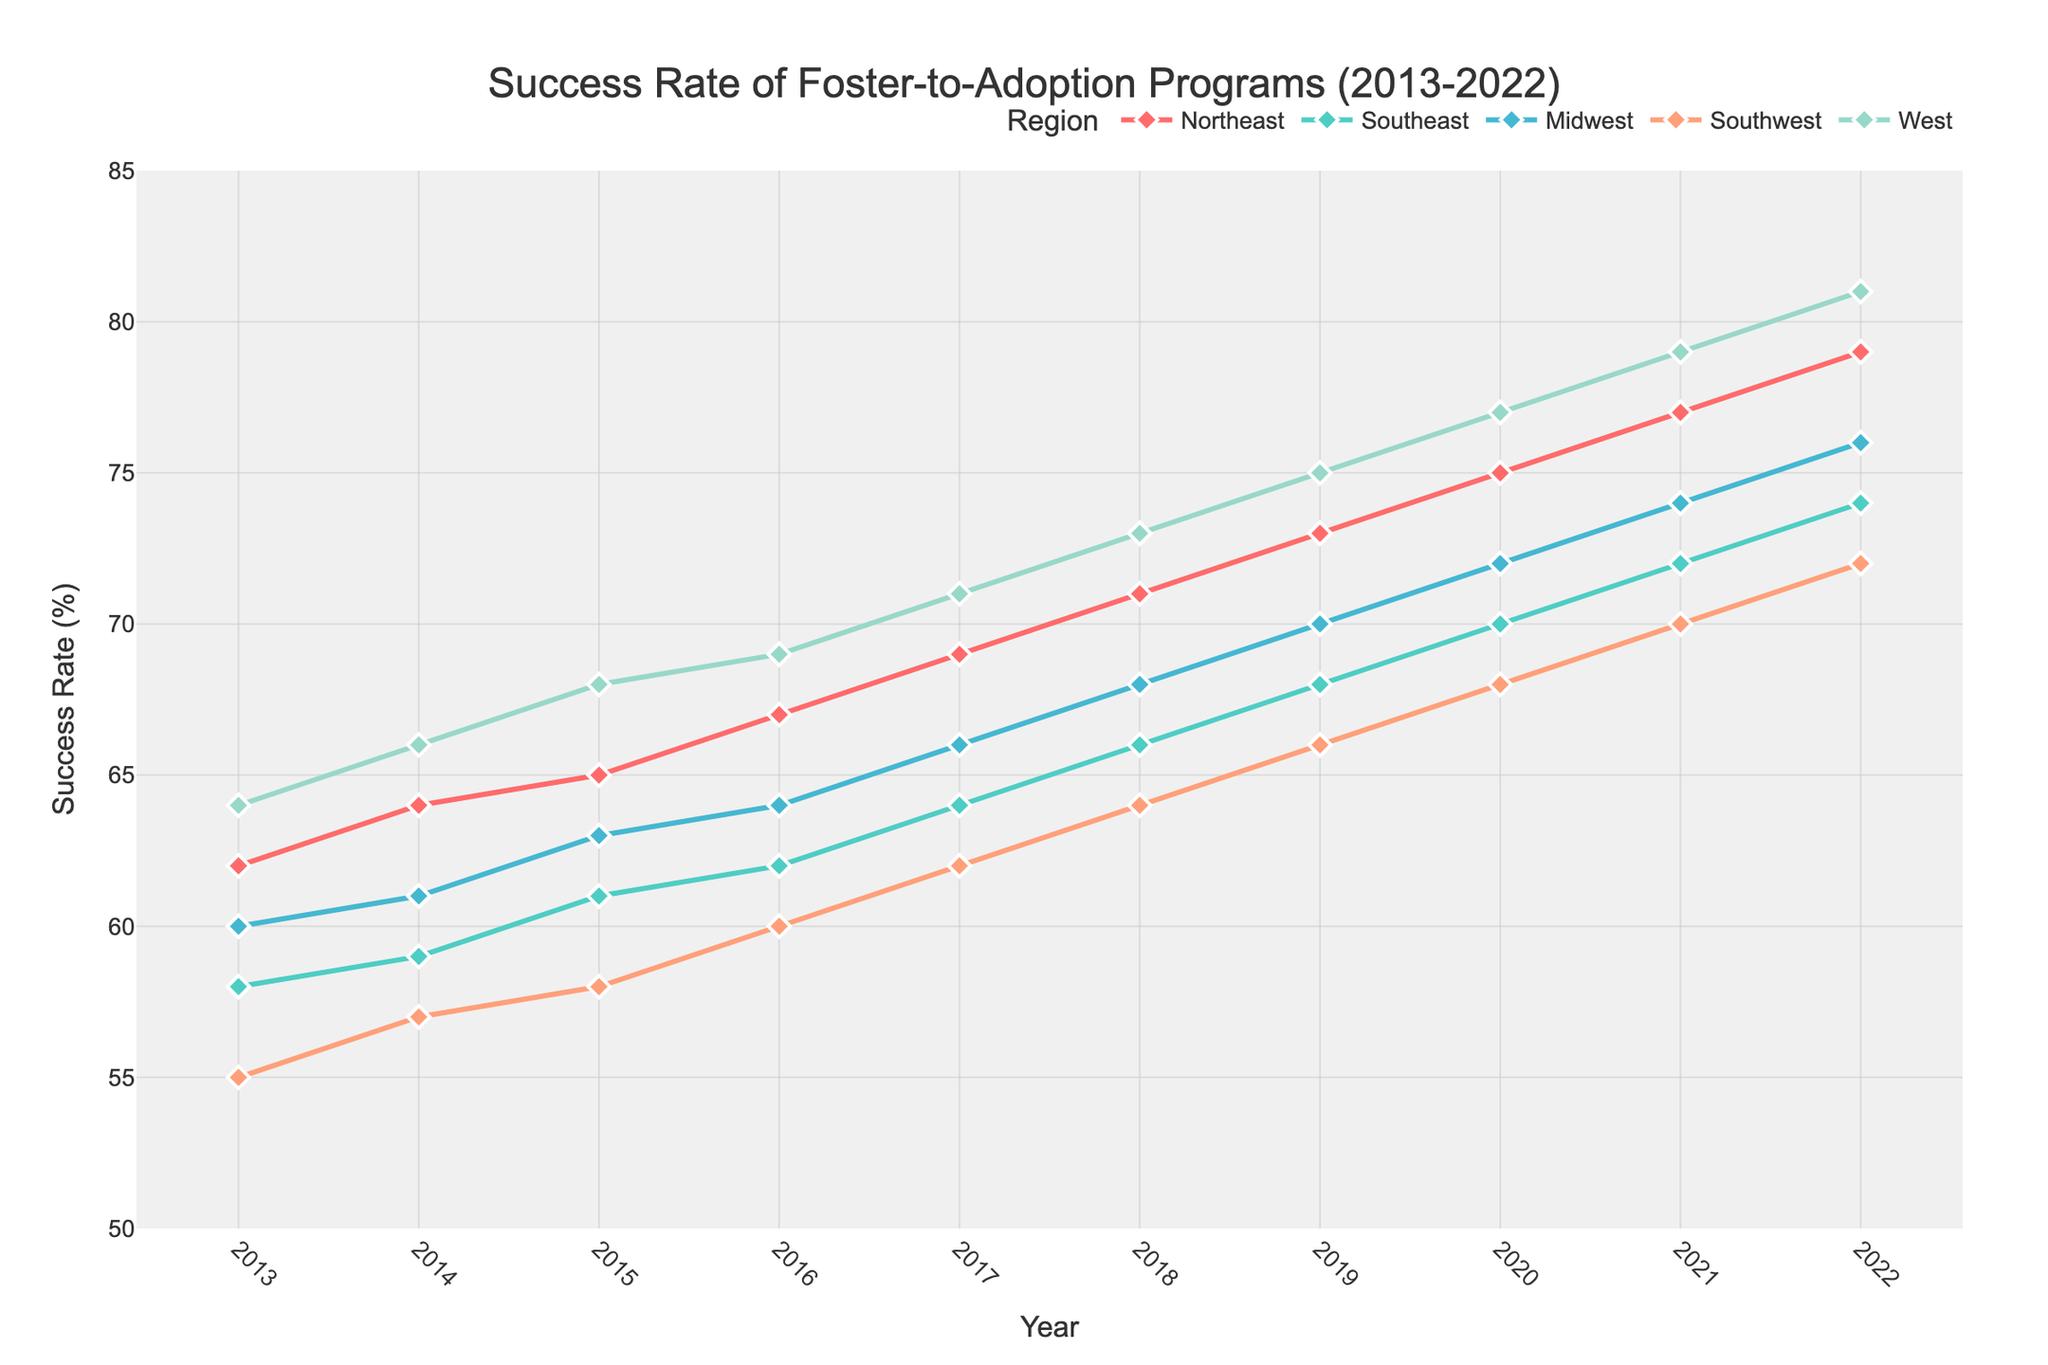What is the success rate of the Midwest region in 2015? Look at the point corresponding to 2015 on the line representing the Midwest region and note the value.
Answer: 63 How does the success rate of the Northeast region in 2014 compare to the West region in the same year? Find the values for both the Northeast and West regions in 2014 and compare them. The Northeast is 64, and the West is 66, so the Northeast has a lower success rate.
Answer: Lower Which region had the highest increase in success rate from 2013 to 2022? Calculate the increase for each region by subtracting their 2013 value from their 2022 value: Northeast (79-62=17), Southeast (74-58=16), Midwest (76-60=16), Southwest (72-55=17), West (81-64=17). The Northeast, Southwest, and West all have the same highest increase.
Answer: Three regions (Northeast, Southwest, West) What's the average success rate of the Southeast region from 2013 to 2022? Sum the success rates of the Southeast region from 2013 to 2022 and divide by the number of years: (58+59+61+62+64+66+68+70+72+74)/10 = 65.4
Answer: 65.4 Which region consistently had the highest success rate throughout the decade? Examine the values for each year and determine which region appears at the topmost position visually in most of the years. The West region consistently has the highest success rate.
Answer: West In which year did the Southwest region surpass the success rate of 60%? Look at the Southwest region line and identify the first year it crosses the 60% mark. In 2016, the success rate is 60%, so it surpasses this in 2017.
Answer: 2017 Compare the success rate of the Northeast and Southeast regions in 2020. Which region performed better? Find the values for both regions in 2020. The Northeast is 75, and the Southeast is 70. The Northeast performed better.
Answer: Northeast What is the total increase in success rate for the Northeast region from 2013 to 2017? Subtract the 2013 value from the 2017 value for the Northeast region: 69 - 62 = 7.
Answer: 7 Which region had the smallest increase in success rates from 2013 to 2017? Calculate the increase for each region by subtracting 2013 values from 2017 values and identify the smallest: Northeast (69-62=7), Southeast (64-58=6), Midwest (66-60=6), Southwest (62-55=7), West (71-64=7). The Southeast and Midwest have the smallest increase.
Answer: Southeast and Midwest 